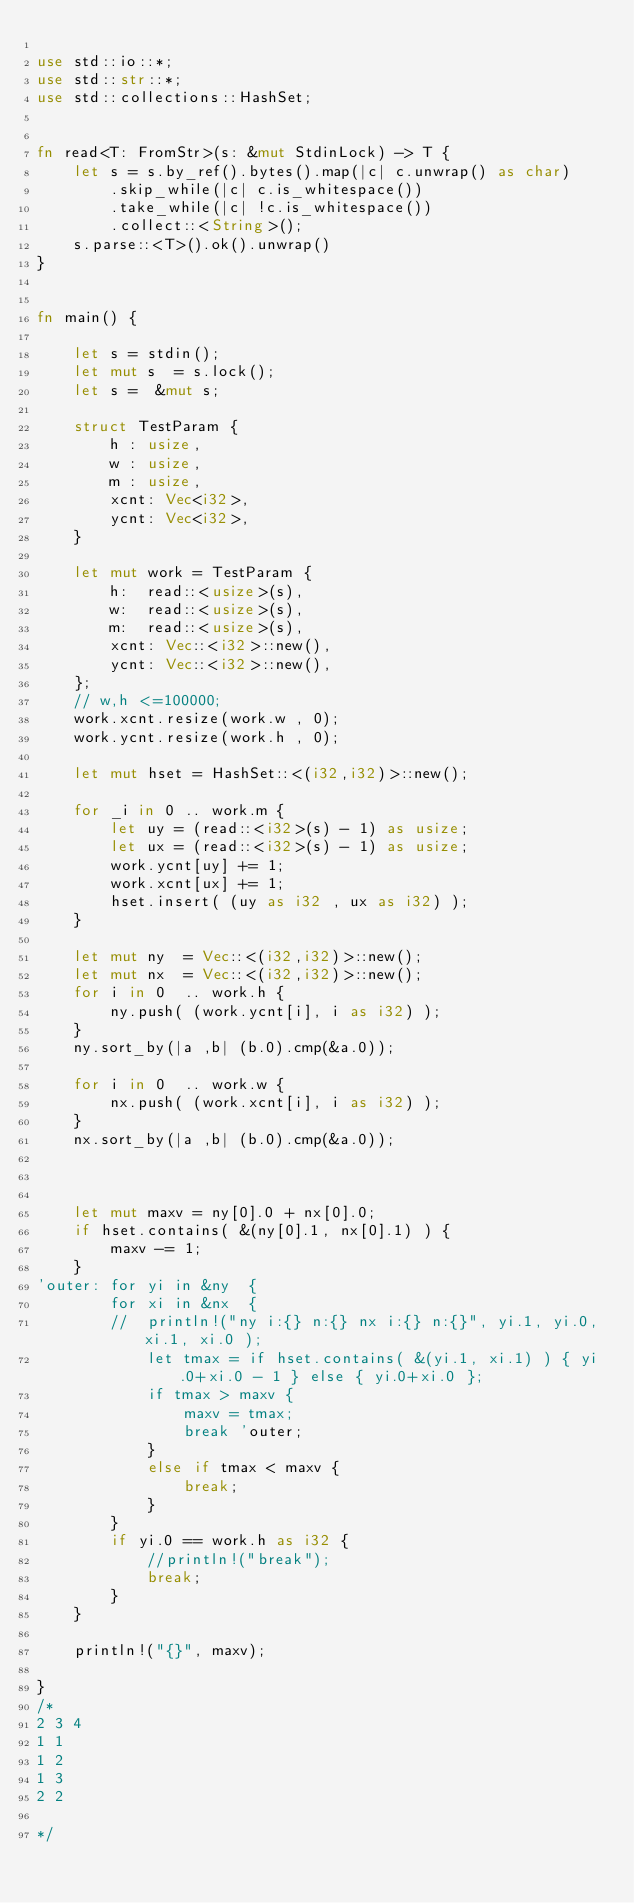Convert code to text. <code><loc_0><loc_0><loc_500><loc_500><_Rust_>
use std::io::*;
use std::str::*;
use std::collections::HashSet;


fn read<T: FromStr>(s: &mut StdinLock) -> T {
    let s = s.by_ref().bytes().map(|c| c.unwrap() as char)
        .skip_while(|c| c.is_whitespace())
        .take_while(|c| !c.is_whitespace())
        .collect::<String>();
    s.parse::<T>().ok().unwrap()
}


fn main() {

	let s = stdin();
	let mut s  = s.lock();
	let s =  &mut s;

	struct TestParam {
		h : usize,
		w : usize,
		m : usize,
		xcnt: Vec<i32>,
		ycnt: Vec<i32>,
	}

	let mut work = TestParam {
		h:  read::<usize>(s),
		w:  read::<usize>(s),
		m:  read::<usize>(s),
		xcnt: Vec::<i32>::new(),
		ycnt: Vec::<i32>::new(),
	};
	// w,h <=100000;
	work.xcnt.resize(work.w , 0);
	work.ycnt.resize(work.h , 0);
	
	let mut hset = HashSet::<(i32,i32)>::new();

	for _i in 0 .. work.m {
		let uy = (read::<i32>(s) - 1) as usize;
		let ux = (read::<i32>(s) - 1) as usize;
		work.ycnt[uy] += 1;
		work.xcnt[ux] += 1;
		hset.insert( (uy as i32 , ux as i32) );
	}

	let mut ny  = Vec::<(i32,i32)>::new();
	let mut nx  = Vec::<(i32,i32)>::new();
	for i in 0  .. work.h {
		ny.push( (work.ycnt[i], i as i32) );
	}
	ny.sort_by(|a ,b| (b.0).cmp(&a.0));

	for i in 0  .. work.w {
		nx.push( (work.xcnt[i], i as i32) );
	}
	nx.sort_by(|a ,b| (b.0).cmp(&a.0));
	
	

	let mut maxv = ny[0].0 + nx[0].0;
	if hset.contains( &(ny[0].1, nx[0].1) ) {
		maxv -= 1;
	}
'outer:	for yi in &ny  {
		for xi in &nx  {
		//	println!("ny i:{} n:{} nx i:{} n:{}", yi.1, yi.0, xi.1, xi.0 );
			let tmax = if hset.contains( &(yi.1, xi.1) ) { yi.0+xi.0 - 1 } else { yi.0+xi.0 };
			if tmax > maxv {
				maxv = tmax;
				break 'outer;
			}
			else if tmax < maxv {
				break;
			}
		}
	 	if yi.0 == work.h as i32 {
	 		//println!("break");
	 		break;
	 	}
	}

	println!("{}", maxv);

}
/*
2 3 4
1 1
1 2
1 3
2 2

*/

</code> 